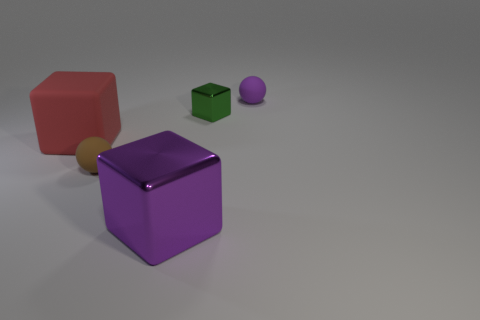Add 2 large cubes. How many objects exist? 7 Subtract all blocks. How many objects are left? 2 Subtract all cubes. Subtract all red blocks. How many objects are left? 1 Add 3 green things. How many green things are left? 4 Add 2 small purple matte things. How many small purple matte things exist? 3 Subtract 0 blue cylinders. How many objects are left? 5 